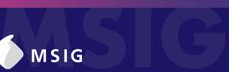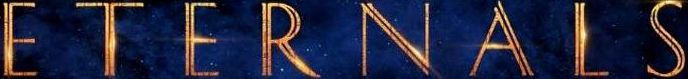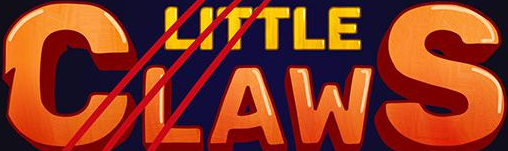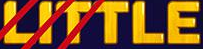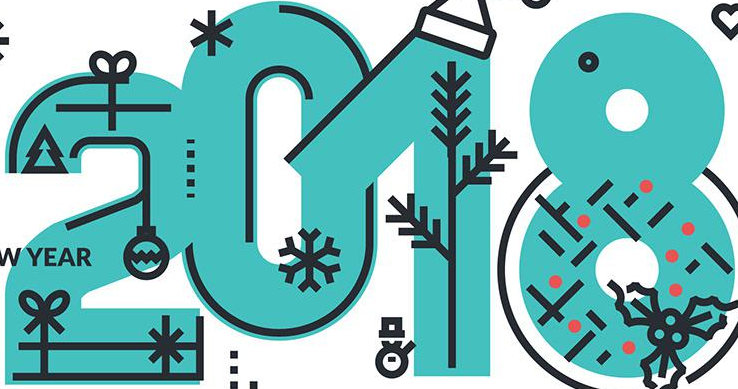What words are shown in these images in order, separated by a semicolon? MSIG; ETERNALS; CLAWS; LITTLE; 2018 